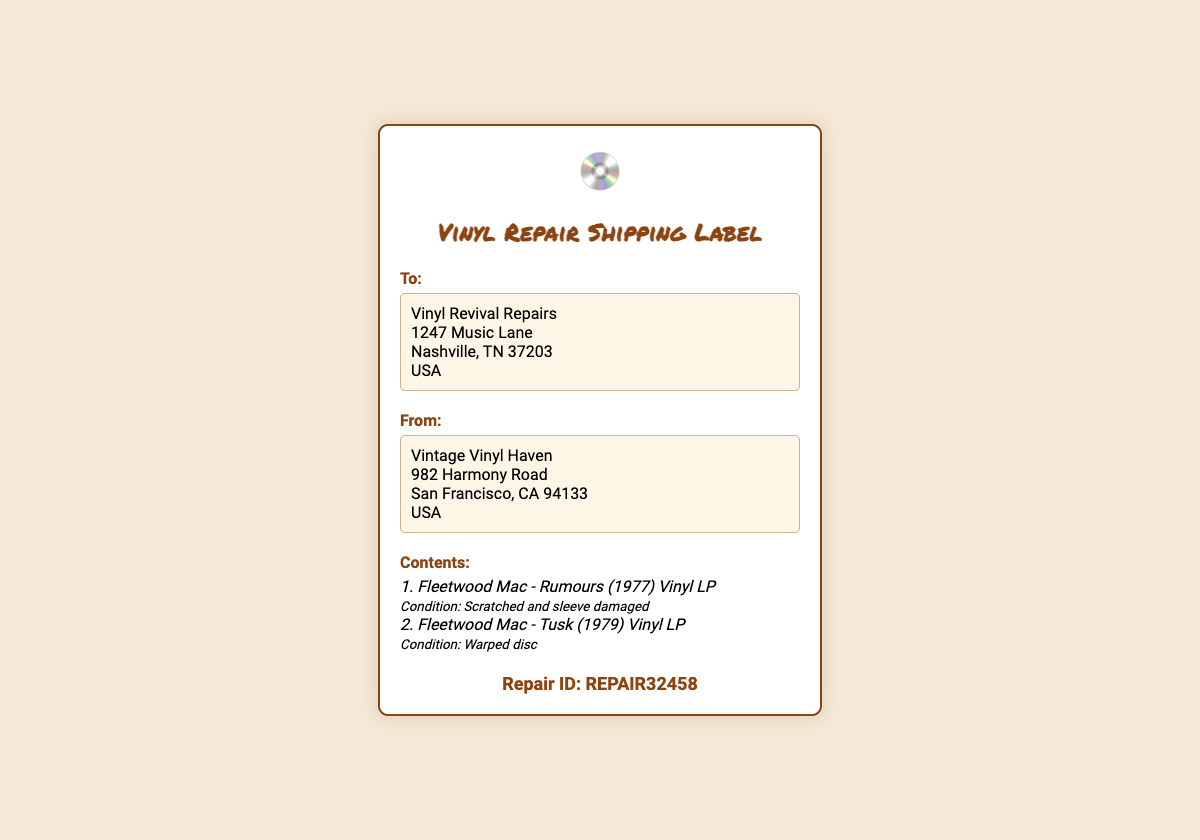What is the repair ID? The repair ID is prominently displayed in the document at the bottom, labeled as "Repair ID: REPAIR32458".
Answer: REPAIR32458 What are the contents of the shipping box? The contents of the shipping box are detailed in the section labeled "Contents," listing two Fleetwood Mac albums with their conditions.
Answer: Fleetwood Mac - Rumours (1977) Vinyl LP, Fleetwood Mac - Tusk (1979) Vinyl LP Where is the repair shop located? The address of the repair shop is "Vinyl Revival Repairs" listed under the "To:" section.
Answer: 1247 Music Lane, Nashville, TN 37203, USA What condition is the Fleetwood Mac - Rumours LP in? The condition of the Fleetwood Mac - Rumours LP is explicitly mentioned in the contents section as "Scratched and sleeve damaged".
Answer: Scratched and sleeve damaged What is the address of the sender? The sender's address is detailed in the "From:" section and includes the name and full address.
Answer: Vintage Vinyl Haven, 982 Harmony Road, San Francisco, CA 94133, USA 